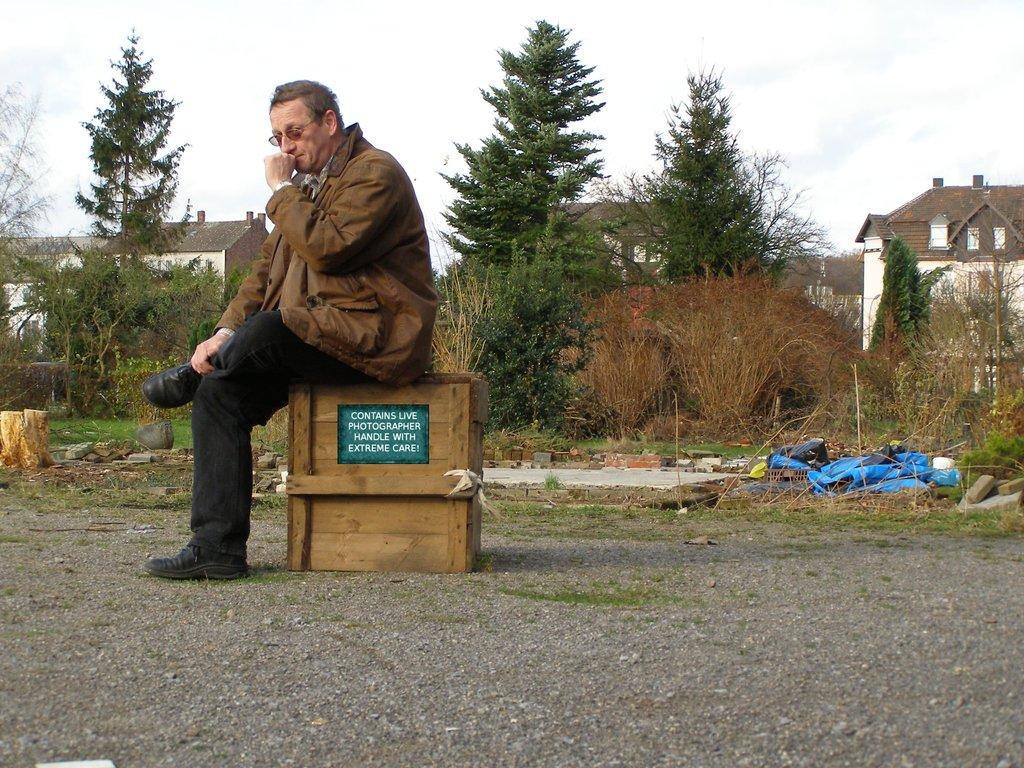What is the man in the image doing? The man is sitting on a box in the image. What type of natural environment is visible in the image? There are trees and grass in the image. What type of structures can be seen in the image? There are buildings in the image. What is visible at the top of the image? The sky is visible at the top of the image. Can you see any signs of a war in the image? There is no indication of war in the image; it features a man sitting on a box, trees, grass, buildings, and the sky. Is the image taken at a seashore? There is no indication of a seashore in the image; it features a man sitting on a box, trees, grass, buildings, and the sky. 